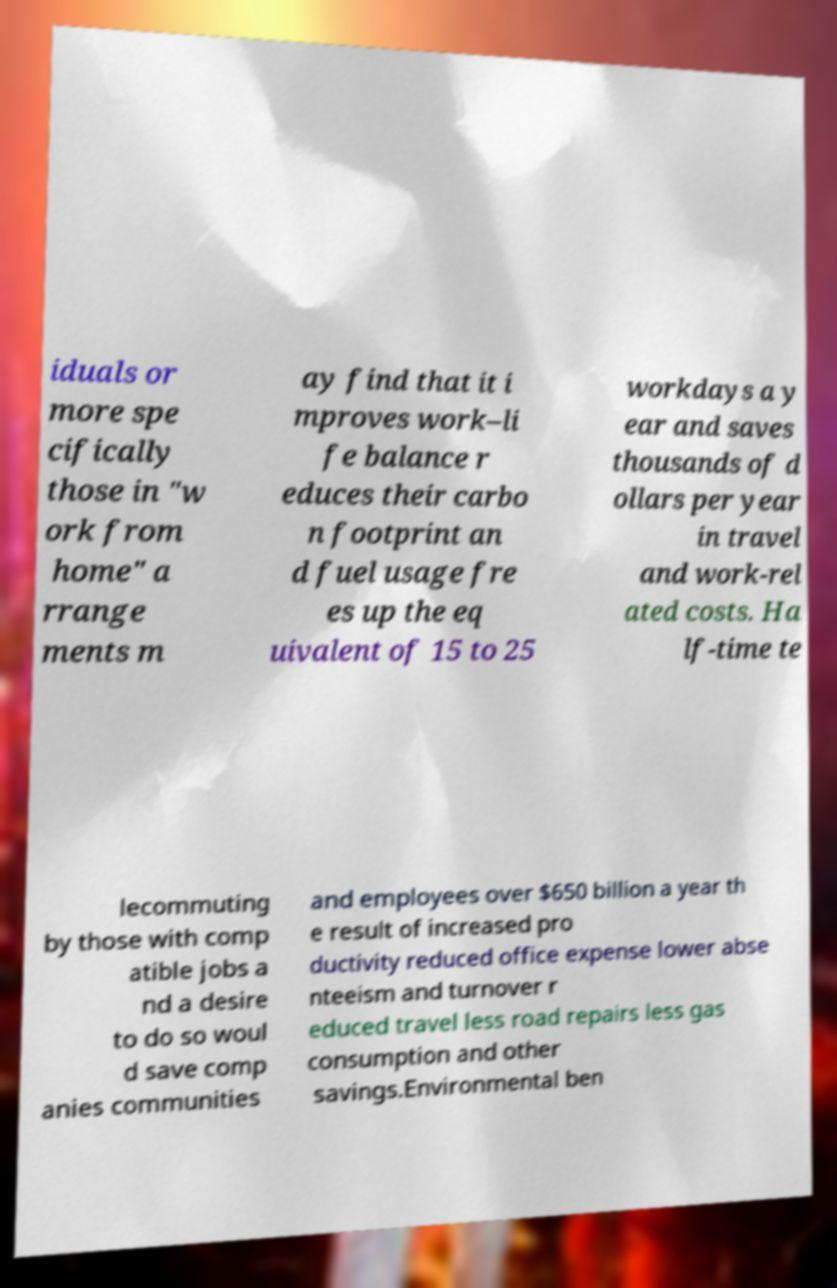Please identify and transcribe the text found in this image. iduals or more spe cifically those in "w ork from home" a rrange ments m ay find that it i mproves work–li fe balance r educes their carbo n footprint an d fuel usage fre es up the eq uivalent of 15 to 25 workdays a y ear and saves thousands of d ollars per year in travel and work-rel ated costs. Ha lf-time te lecommuting by those with comp atible jobs a nd a desire to do so woul d save comp anies communities and employees over $650 billion a year th e result of increased pro ductivity reduced office expense lower abse nteeism and turnover r educed travel less road repairs less gas consumption and other savings.Environmental ben 